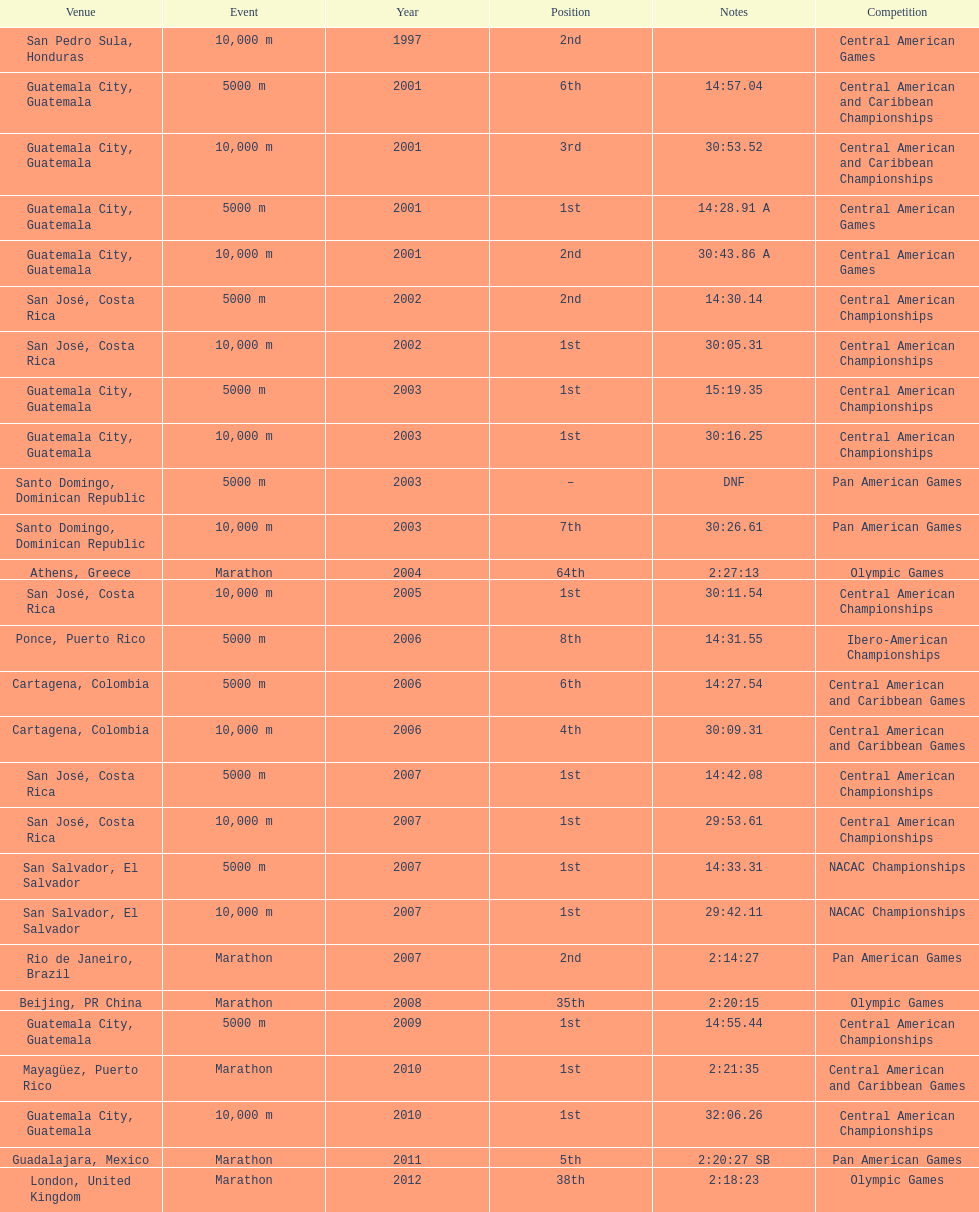How many times has this athlete not finished in a competition? 1. 